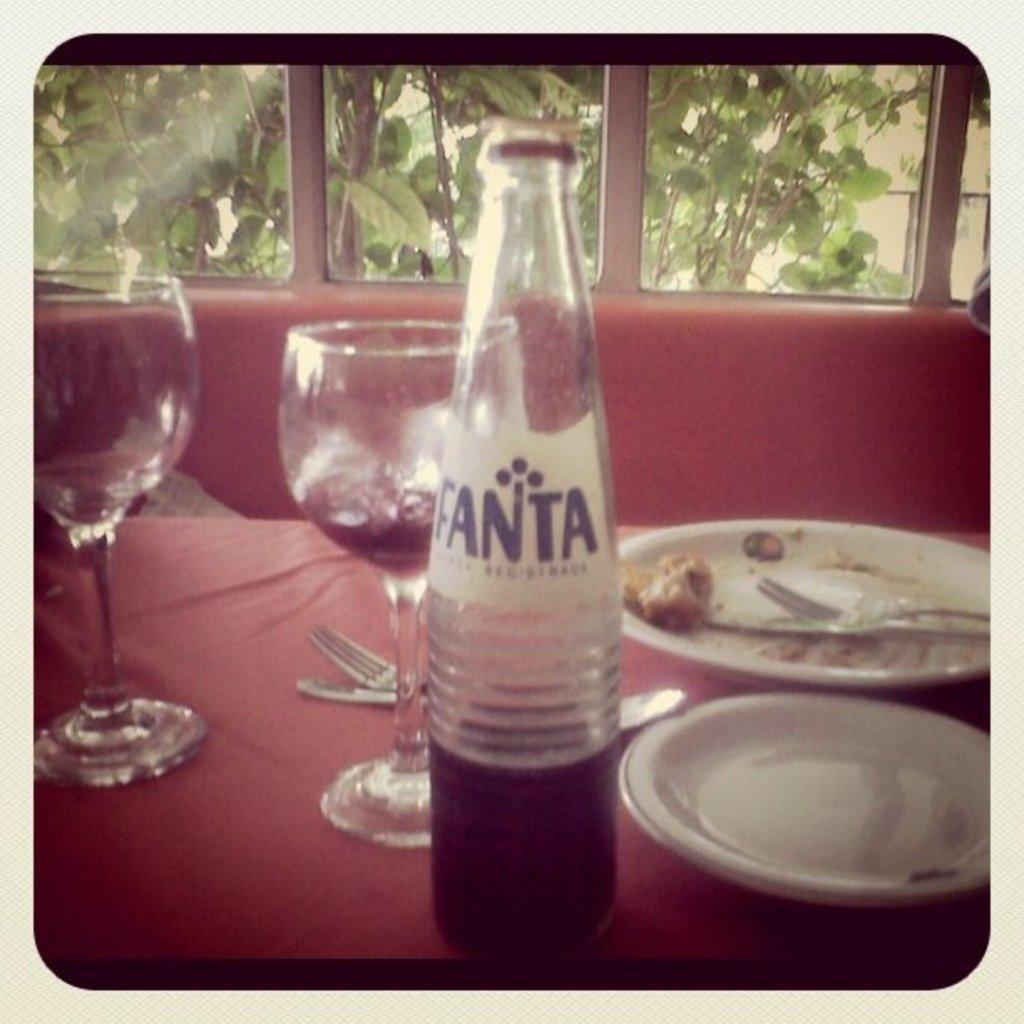Please provide a concise description of this image. In the middle of the image there is a table on the table there are two glasses and there is a bottle and there are two plates and spoons and forks. At the top of the image there is a glass window. Through the glass window we can see some trees. 